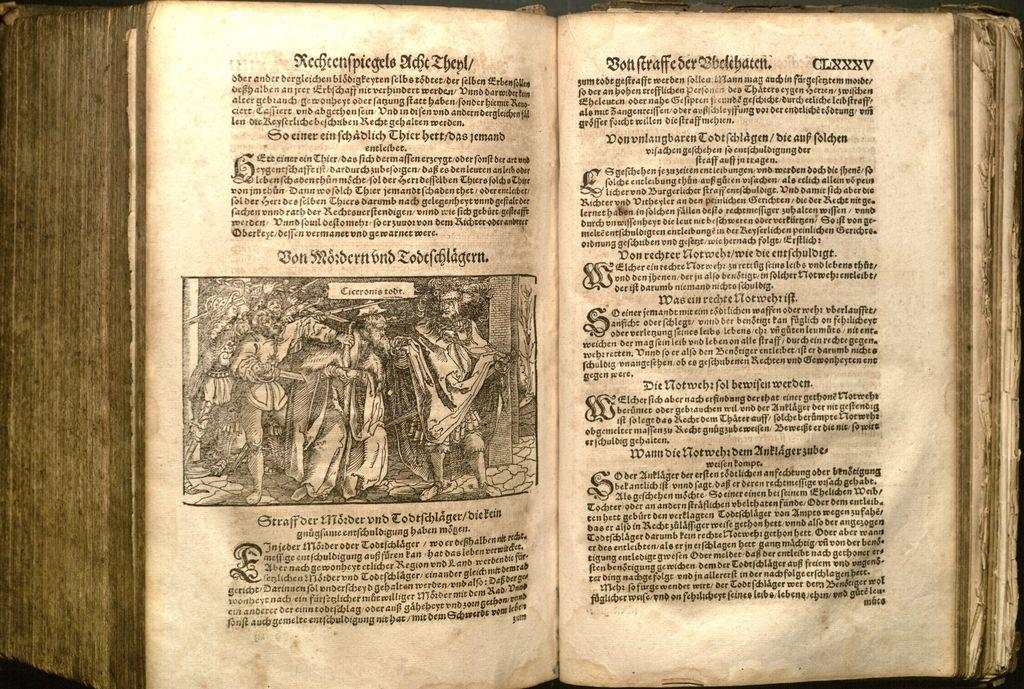Provide a one-sentence caption for the provided image. A vintage book is opened to page CLXXXV, marked in the upper right corner. 